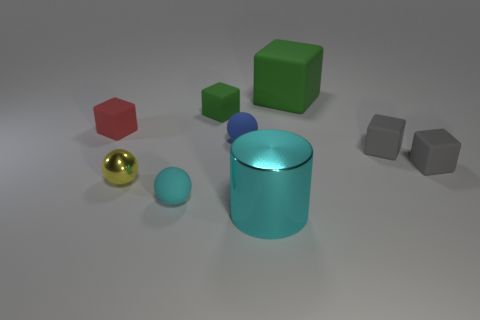Is the size of the blue object that is behind the tiny yellow thing the same as the matte ball in front of the tiny metallic object?
Make the answer very short. Yes. Are there fewer blue matte spheres than large brown rubber cubes?
Offer a terse response. No. What number of large cyan objects are left of the large green matte thing?
Provide a succinct answer. 1. What material is the small blue thing?
Make the answer very short. Rubber. Do the big shiny object and the small shiny ball have the same color?
Your answer should be very brief. No. Are there fewer tiny yellow shiny balls that are in front of the small cyan thing than big green matte objects?
Provide a succinct answer. Yes. What is the color of the rubber sphere in front of the yellow metal thing?
Provide a succinct answer. Cyan. What is the shape of the large rubber thing?
Your answer should be very brief. Cube. Is there a small yellow metal ball to the right of the tiny matte cube behind the small matte block that is on the left side of the cyan matte sphere?
Your answer should be very brief. No. There is a metal thing to the left of the sphere that is to the right of the green matte object on the left side of the large green rubber cube; what color is it?
Your answer should be compact. Yellow. 